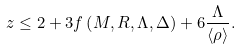<formula> <loc_0><loc_0><loc_500><loc_500>z \leq 2 + 3 f \left ( M , R , \Lambda , \Delta \right ) + 6 \frac { \Lambda } { \langle \rho \rangle } .</formula> 